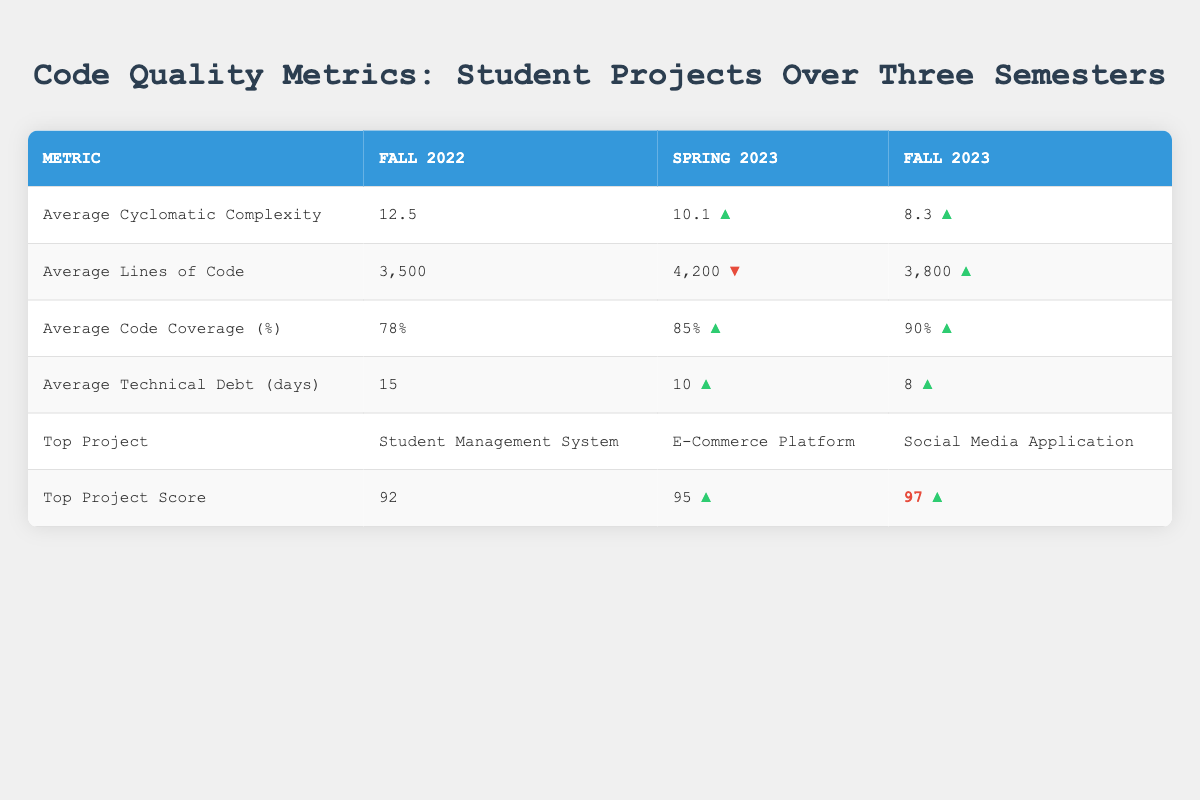What was the top project in Spring 2023? The table indicates that the top project in Spring 2023 is the "E-Commerce Platform."
Answer: E-Commerce Platform What is the average technical debt in Fall 2023? According to the table, the average technical debt in Fall 2023 is 8 days.
Answer: 8 days Which semester had the highest average lines of code? The data shows that Spring 2023 had the highest average lines of code at 4,200.
Answer: Spring 2023 Is the average cyclomatic complexity improving over the semesters? By comparing the values, Fall 2022 had 12.5, Spring 2023 had 10.1, and Fall 2023 had 8.3, indicating decreasing complexity. Thus, it is improving.
Answer: Yes Calculate the difference in average code coverage percentage between Fall 2022 and Fall 2023. Fall 2022 had 78% and Fall 2023 had 90%. The difference is 90 - 78 = 12%.
Answer: 12% What was the trend in average technical debt from Fall 2022 to Spring 2023? In Fall 2022, the average technical debt was 15 days and in Spring 2023, it decreased to 10 days, indicating an improvement in technical debt.
Answer: Improved What is the average cyclomatic complexity for all three semesters combined? To find the average cyclomatic complexity, add the values: 12.5 + 10.1 + 8.3 = 30.9. Then divide by 3, resulting in 30.9 / 3 = 10.3.
Answer: 10.3 Which semester had the highest top project score? The top project score for Fall 2023 was 97, which is higher than the scores for Fall 2022 (92) and Spring 2023 (95). Therefore, Fall 2023 had the highest score.
Answer: Fall 2023 What is the overall trend in average code coverage from Fall 2022 to Fall 2023? The average code coverage improved from 78% in Fall 2022 to 90% in Fall 2023, indicating a positive trend in code quality.
Answer: Improved How much did the average lines of code decrease from Spring 2023 to Fall 2023? In Spring 2023, the average lines of code were 4,200, and in Fall 2023, it was 3,800. The decrease is calculated as 4,200 - 3,800 = 400.
Answer: 400 